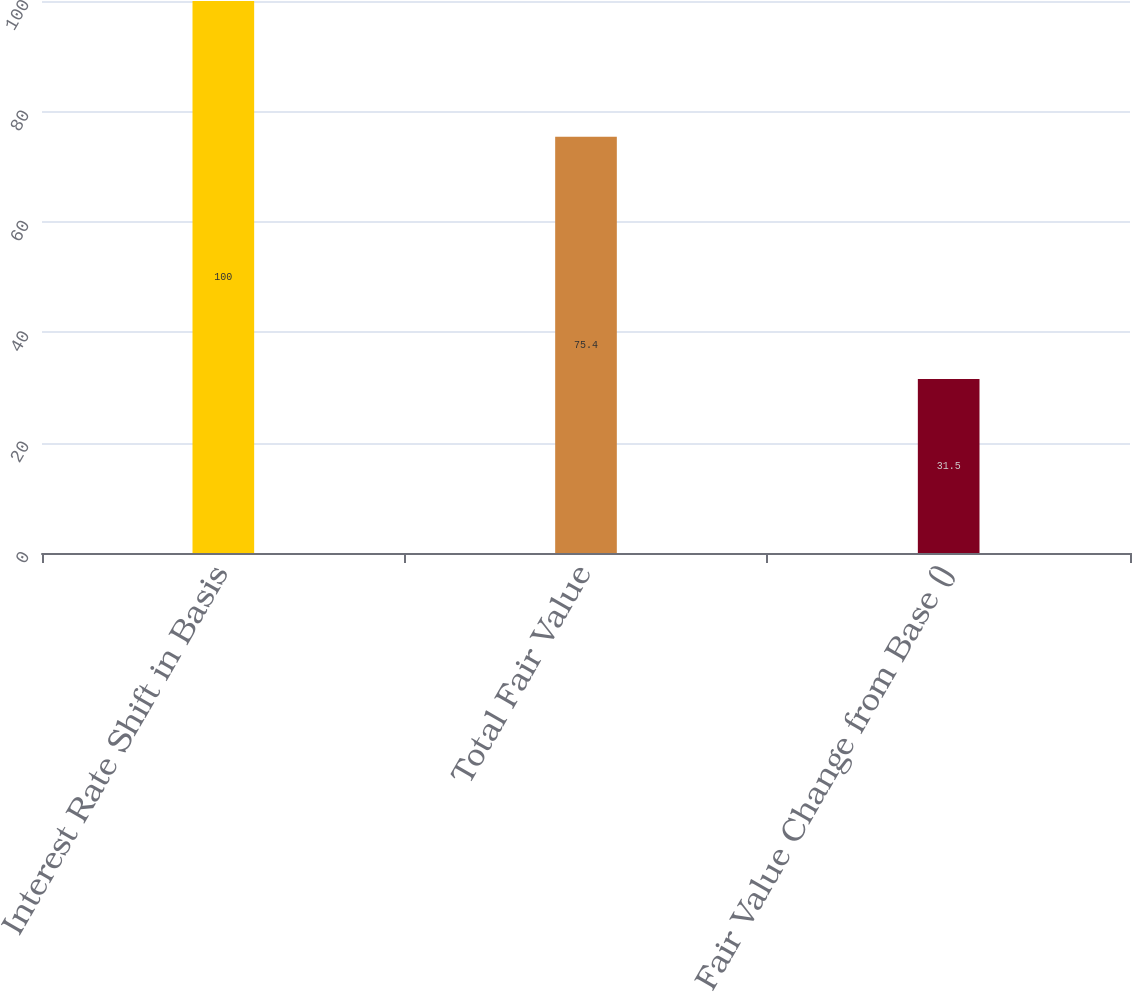Convert chart to OTSL. <chart><loc_0><loc_0><loc_500><loc_500><bar_chart><fcel>Interest Rate Shift in Basis<fcel>Total Fair Value<fcel>Fair Value Change from Base ()<nl><fcel>100<fcel>75.4<fcel>31.5<nl></chart> 